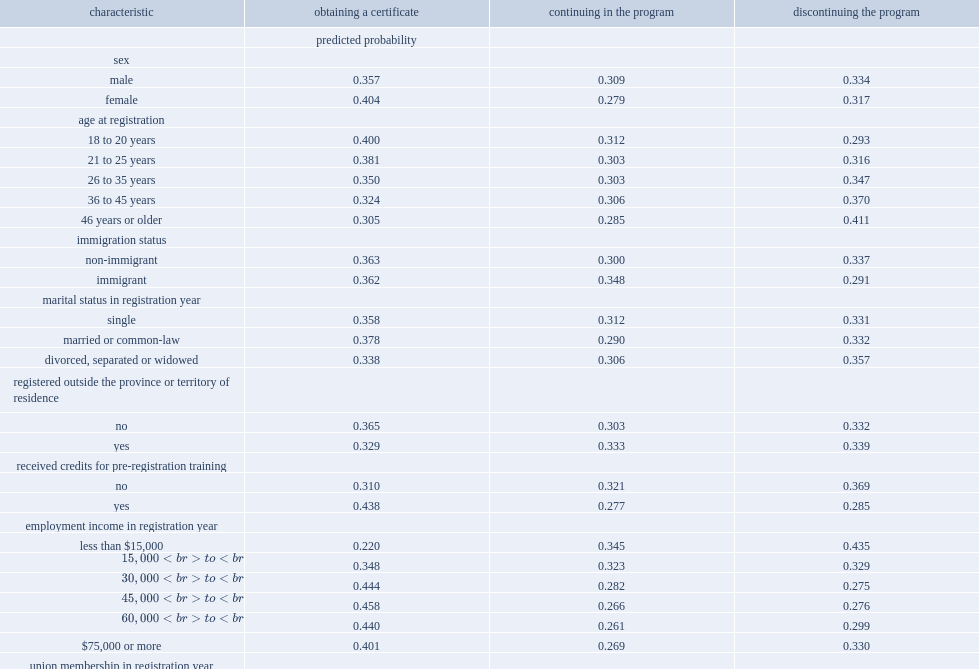Which group of people is more likely to complete their apprenticeship program, apprentices who receive credits or apprentices who have no credits? Received credits for pre-registration training yes. Which group of people is less likely to leave their program, apprentices who receive credits or apprentices who have no credits? Received credits for pre-registration training yes. Which group of people is less likely to be continuing in the program, apprentices who receive credits or apprentices who have no credits? Received credits for pre-registration training yes. Which group of people is more likely to be more likely to earn their certificate, apprentices who are working in one of the three most common sectors during the registration year or those who work in less prevalent sectors? Worked in one the three most common sectors in registration year yes. Which group of people is less likely to leave their program, apprentices who are union members in the registration year or apprentices who are not union members? Union membership in registration year yes. Which group of people is more likely to continue in the program, apprentices who are union members in the registration year or apprentices who are not union members? Union membership in registration year. Which group of people is more likely to become certified, apprentices who have well-paying apprenticeship positions or those who are in low income? Not in low income. What percentage is apprentices who earned between $45,000 and $59,999 in the registration year more likely to become certified than those who earned between $15,000 and $29,999? 0.11. 